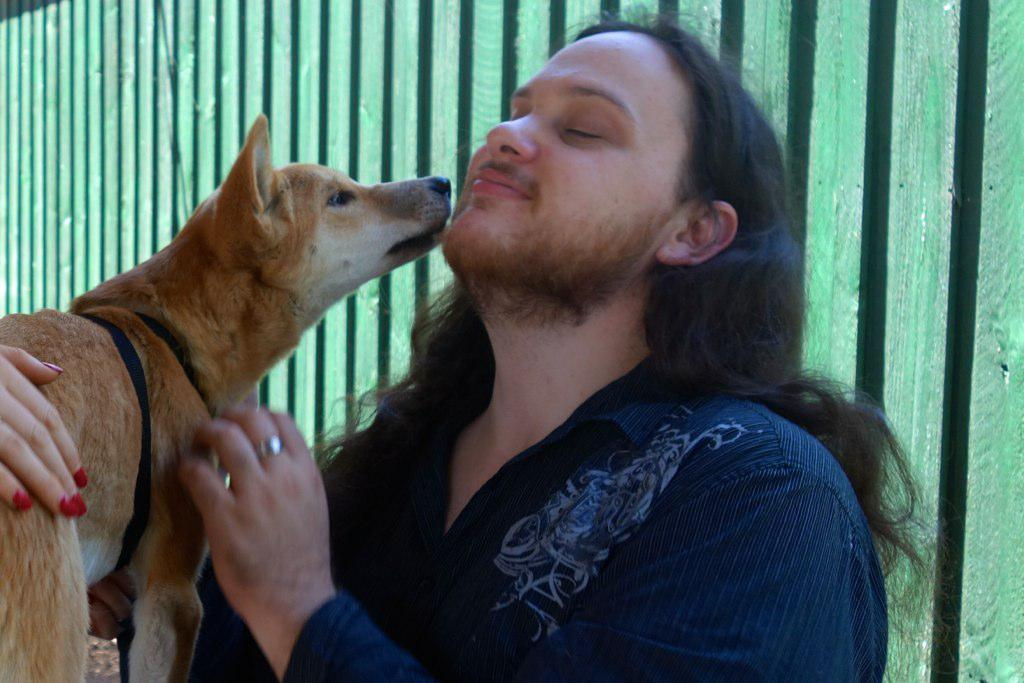What is the main subject in the image? There is a man in the image. What is the man doing in the image? The man is standing and holding a dog. Can you describe the dog in the image? The dog is being held by the man and has another human hand on it. What can be seen in the background of the image? There is a wooden fence in the image. What type of pencil can be seen in the image? There is no pencil present in the image. What is the man's reaction to the store in the image? There is no store present in the image, so the man's reaction cannot be determined. 